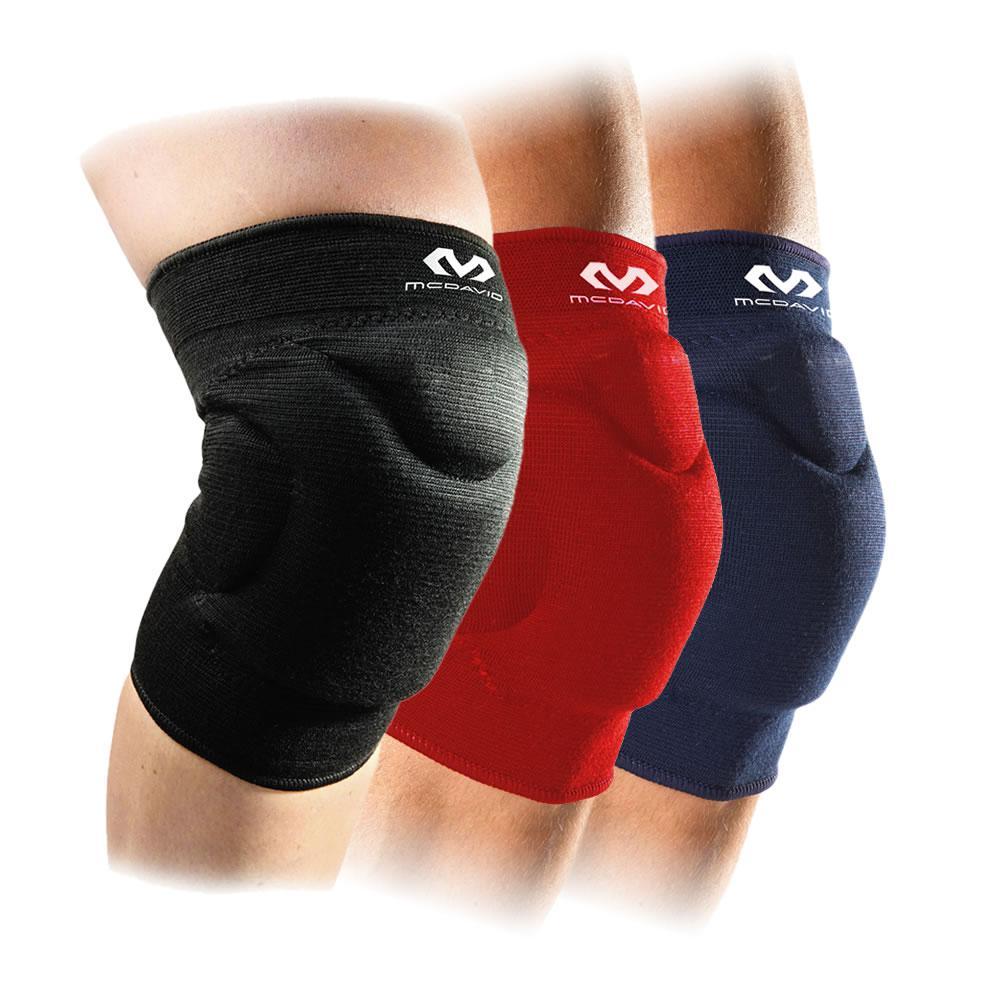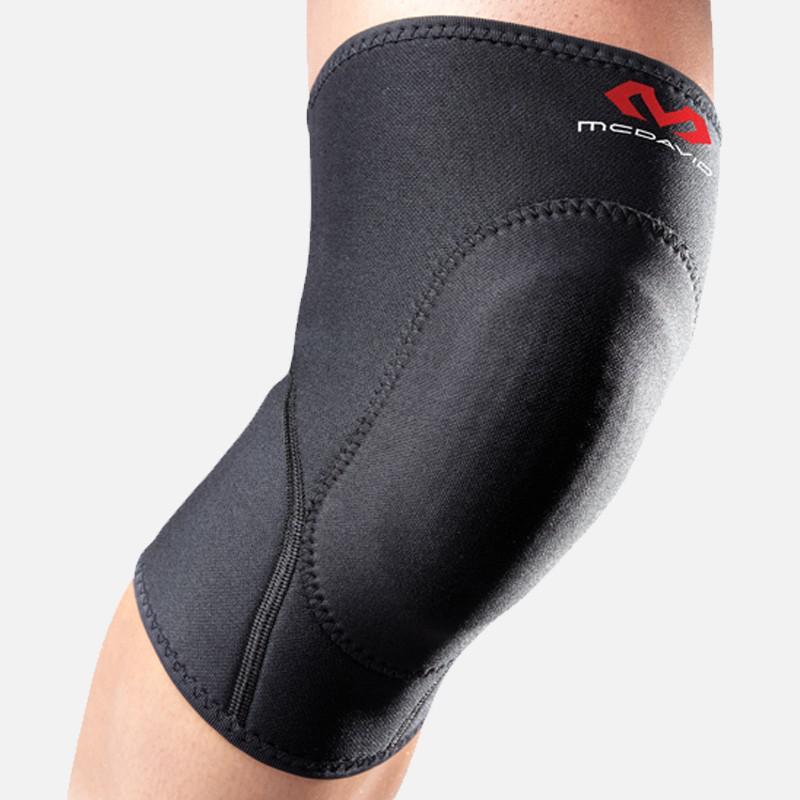The first image is the image on the left, the second image is the image on the right. For the images shown, is this caption "There are exactly two knee braces." true? Answer yes or no. No. The first image is the image on the left, the second image is the image on the right. Considering the images on both sides, is "Exactly two kneepads are modeled on human legs, both of the pads black with a logo, but different designs." valid? Answer yes or no. No. 